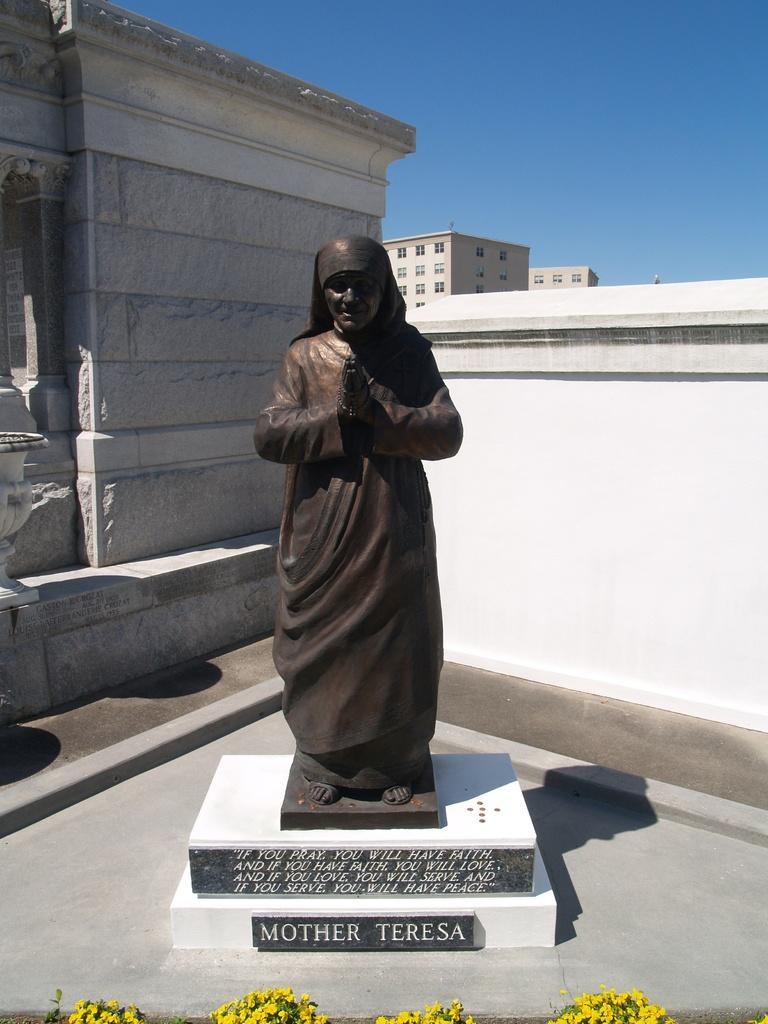Please provide a concise description of this image. In this picture I can see a statue and few buildings and I can see text on the stones and few flowers. 